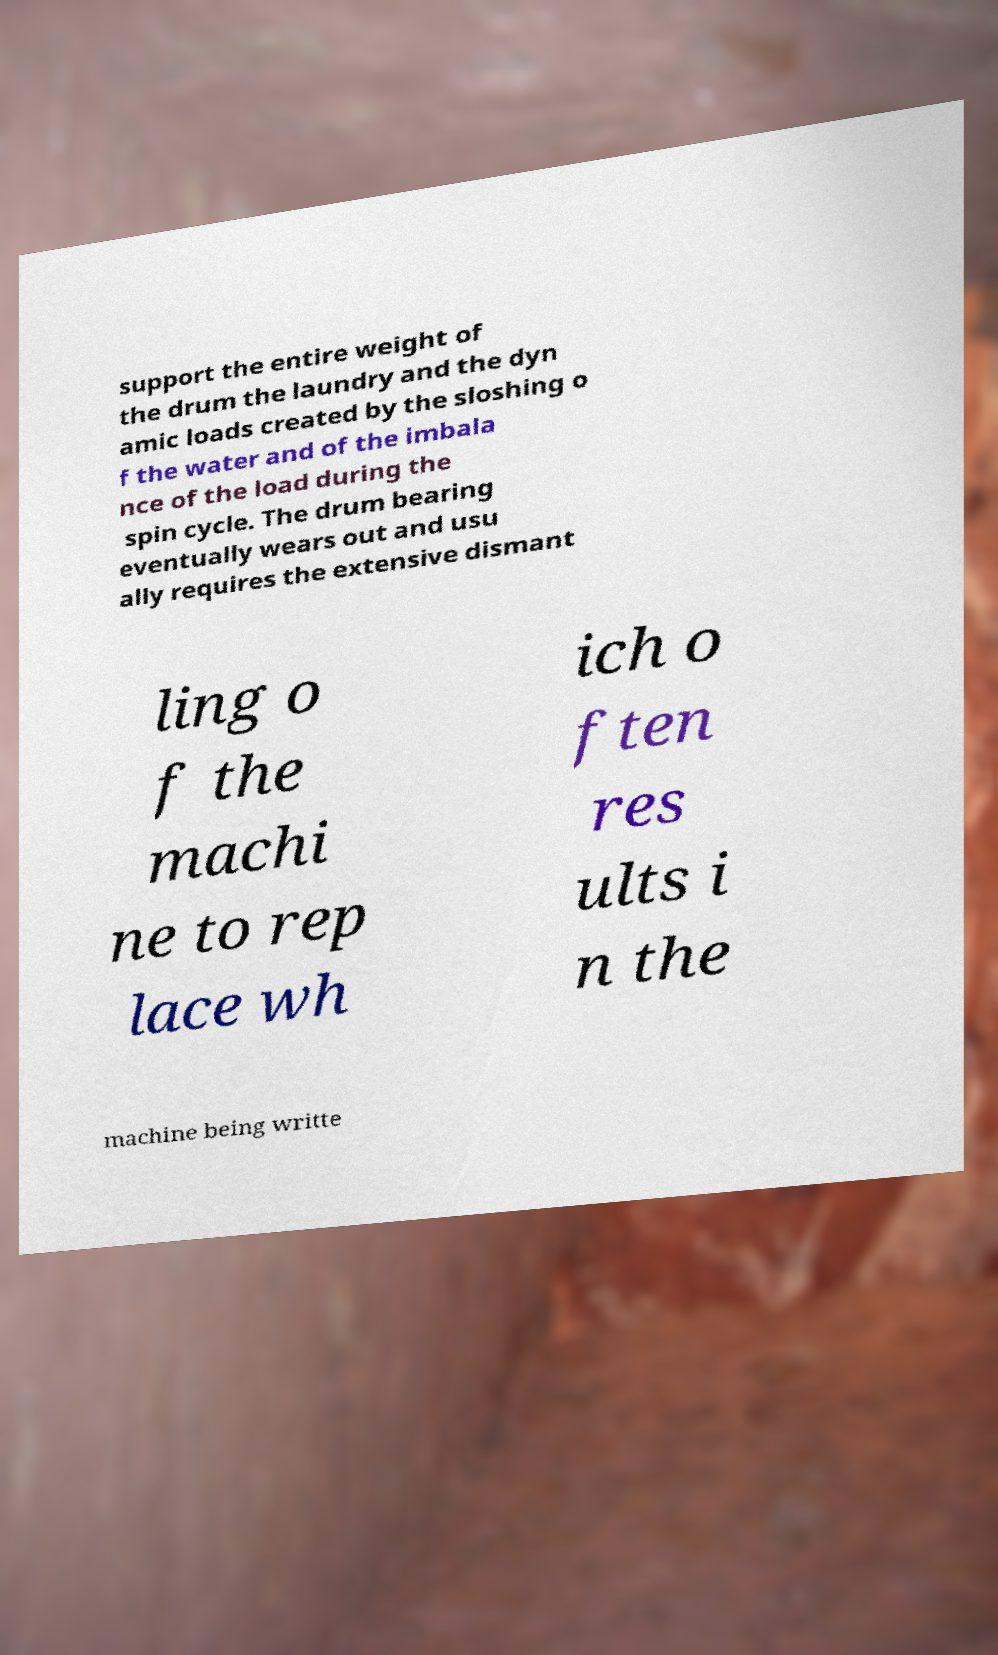I need the written content from this picture converted into text. Can you do that? support the entire weight of the drum the laundry and the dyn amic loads created by the sloshing o f the water and of the imbala nce of the load during the spin cycle. The drum bearing eventually wears out and usu ally requires the extensive dismant ling o f the machi ne to rep lace wh ich o ften res ults i n the machine being writte 